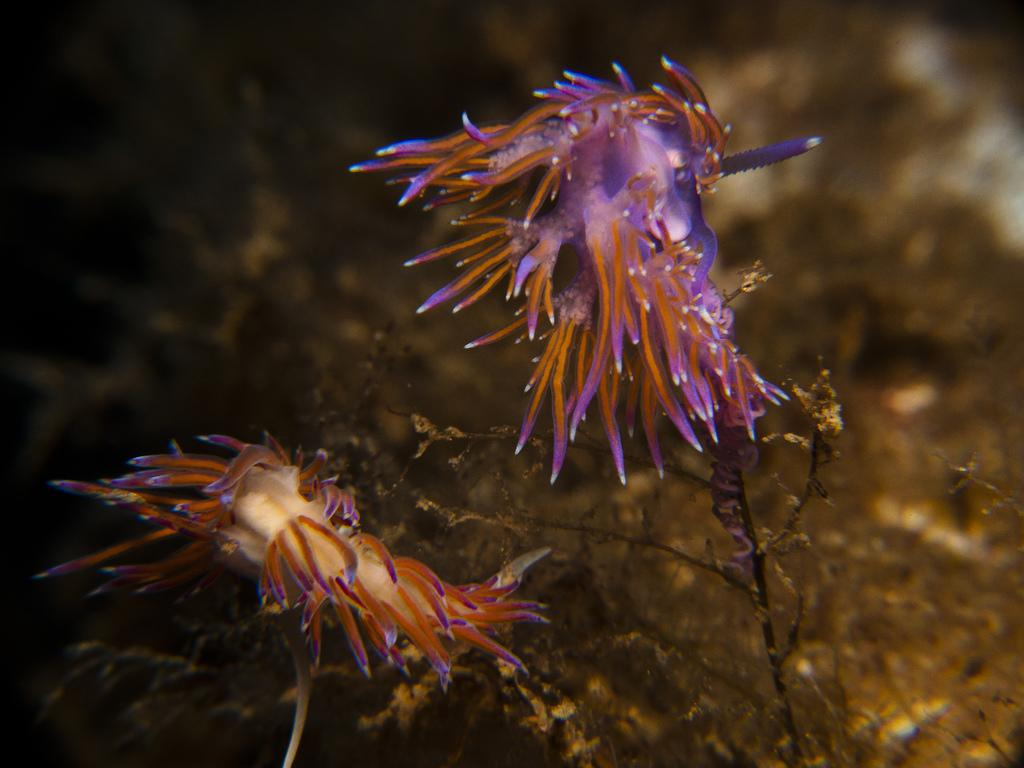What type of plants can be seen in the image? The plants in the image appear to be aquatic. Can you describe the background of the image? The background of the image is blurry. What type of airplane can be seen flying in the background of the image? There is no airplane visible in the image; the background is blurry and only aquatic plants are present. 